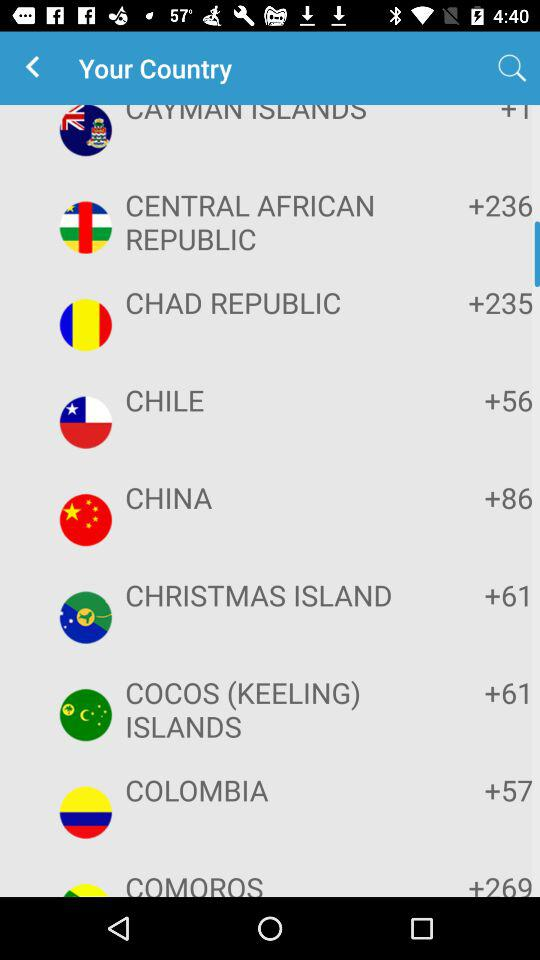What is the code for Comoros? The code for Comoros is +269. 